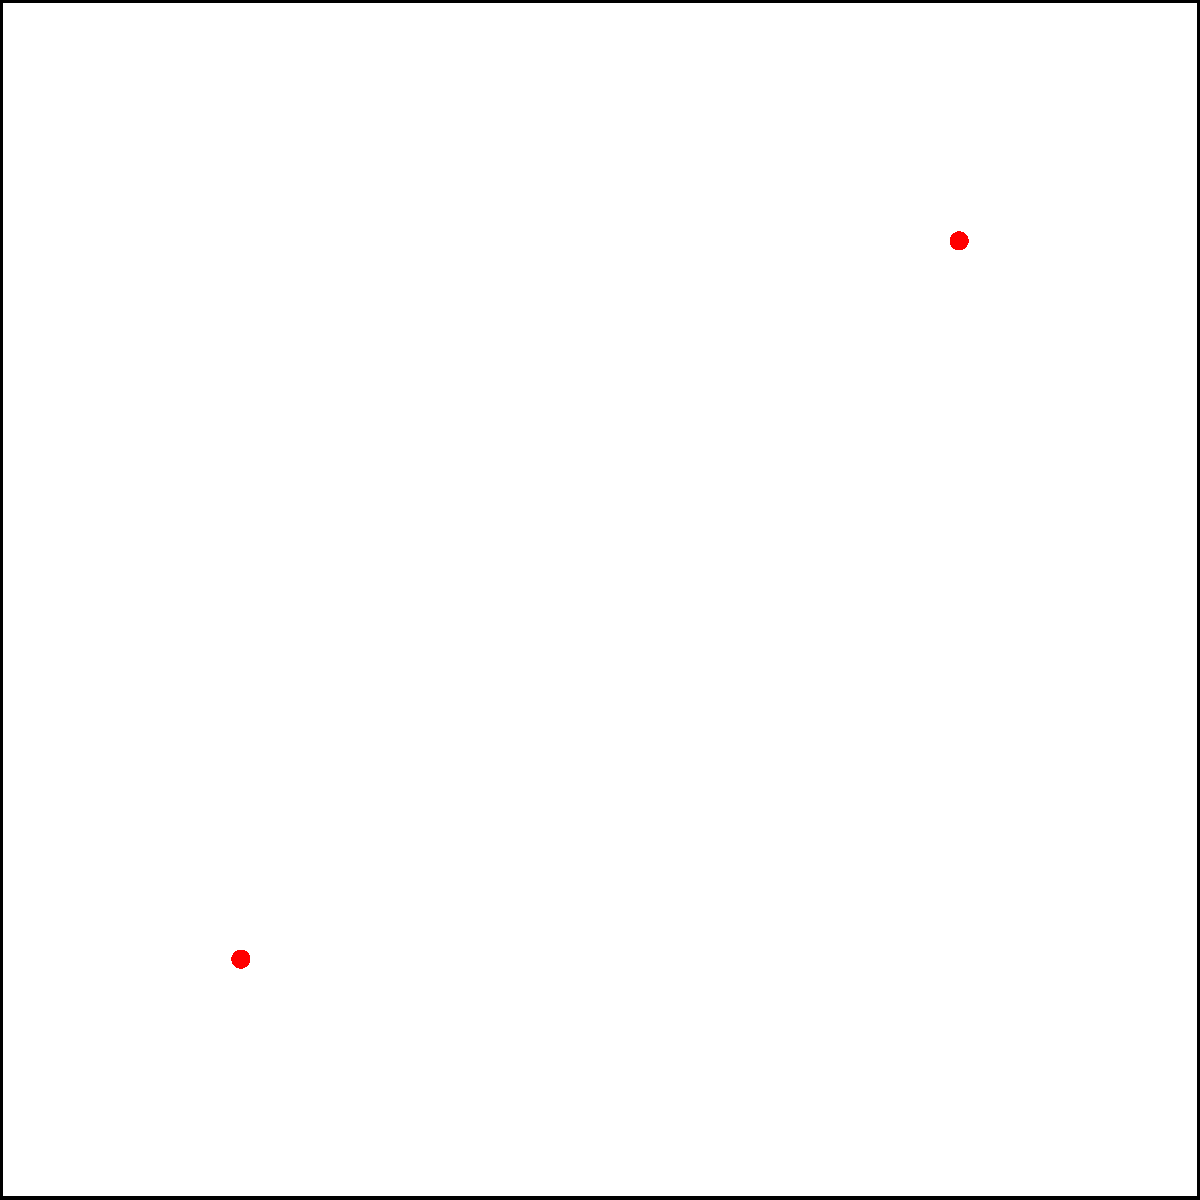A rectangular dance floor measures 10m x 10m and has two overhead light sources, L1 and L2, positioned at coordinates (2m, 2m) and (8m, 8m) respectively. Each light source emits light with an intensity that follows the inverse square law, given by the formula $I(x,y) = \frac{100}{1 + ((x-x_0)^2 + (y-y_0)^2)}$, where $(x_0, y_0)$ is the position of the light source and the intensity is measured in arbitrary units. Calculate the total light intensity at the center of the dance floor (5m, 5m). To solve this problem, we'll follow these steps:

1) The total intensity at any point is the sum of the intensities from both light sources.

2) For light source L1 at (2m, 2m):
   $I_1(x,y) = \frac{100}{1 + ((x-2)^2 + (y-2)^2)}$

3) For light source L2 at (8m, 8m):
   $I_2(x,y) = \frac{100}{1 + ((x-8)^2 + (y-8)^2)}$

4) The center of the dance floor is at (5m, 5m).

5) For L1 at the center:
   $I_1(5,5) = \frac{100}{1 + ((5-2)^2 + (5-2)^2)} = \frac{100}{1 + (3^2 + 3^2)} = \frac{100}{19} \approx 5.26$

6) For L2 at the center:
   $I_2(5,5) = \frac{100}{1 + ((5-8)^2 + (5-8)^2)} = \frac{100}{1 + ((-3)^2 + (-3)^2)} = \frac{100}{19} \approx 5.26$

7) The total intensity is the sum of these two:
   $I_{total} = I_1(5,5) + I_2(5,5) = \frac{100}{19} + \frac{100}{19} = \frac{200}{19} \approx 10.53$
Answer: $\frac{200}{19}$ (or approximately 10.53) arbitrary units 